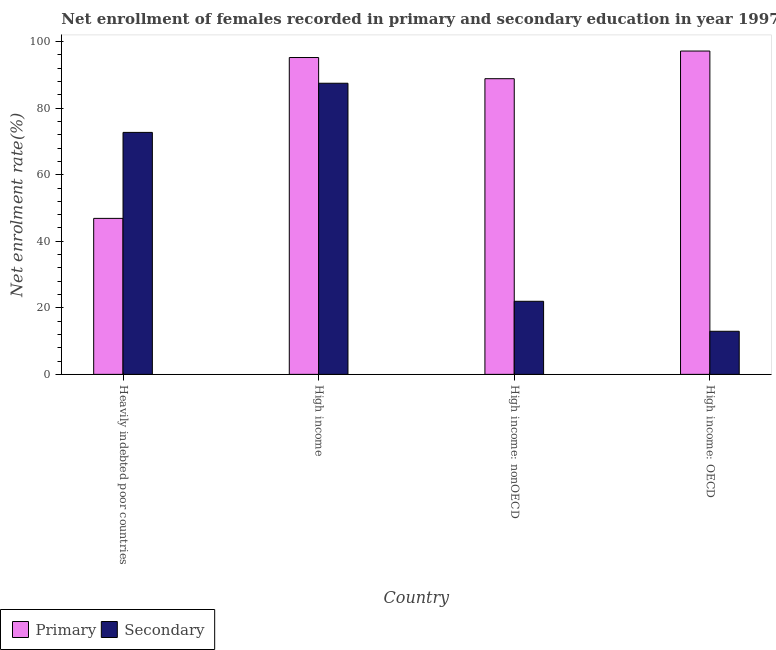How many different coloured bars are there?
Your answer should be compact. 2. How many groups of bars are there?
Ensure brevity in your answer.  4. Are the number of bars per tick equal to the number of legend labels?
Your answer should be compact. Yes. Are the number of bars on each tick of the X-axis equal?
Ensure brevity in your answer.  Yes. How many bars are there on the 3rd tick from the left?
Keep it short and to the point. 2. What is the label of the 1st group of bars from the left?
Your answer should be compact. Heavily indebted poor countries. What is the enrollment rate in secondary education in High income: OECD?
Offer a very short reply. 12.95. Across all countries, what is the maximum enrollment rate in secondary education?
Offer a terse response. 87.49. Across all countries, what is the minimum enrollment rate in primary education?
Offer a very short reply. 46.88. In which country was the enrollment rate in primary education maximum?
Provide a short and direct response. High income: OECD. In which country was the enrollment rate in secondary education minimum?
Provide a short and direct response. High income: OECD. What is the total enrollment rate in primary education in the graph?
Provide a short and direct response. 328.13. What is the difference between the enrollment rate in primary education in Heavily indebted poor countries and that in High income: OECD?
Provide a short and direct response. -50.29. What is the difference between the enrollment rate in secondary education in High income: nonOECD and the enrollment rate in primary education in High income?
Offer a very short reply. -73.26. What is the average enrollment rate in secondary education per country?
Your response must be concise. 48.78. What is the difference between the enrollment rate in primary education and enrollment rate in secondary education in High income: nonOECD?
Offer a terse response. 66.9. In how many countries, is the enrollment rate in primary education greater than 48 %?
Give a very brief answer. 3. What is the ratio of the enrollment rate in primary education in High income to that in High income: nonOECD?
Provide a succinct answer. 1.07. Is the difference between the enrollment rate in primary education in High income and High income: nonOECD greater than the difference between the enrollment rate in secondary education in High income and High income: nonOECD?
Offer a very short reply. No. What is the difference between the highest and the second highest enrollment rate in secondary education?
Make the answer very short. 14.77. What is the difference between the highest and the lowest enrollment rate in primary education?
Make the answer very short. 50.29. In how many countries, is the enrollment rate in secondary education greater than the average enrollment rate in secondary education taken over all countries?
Provide a short and direct response. 2. Is the sum of the enrollment rate in secondary education in Heavily indebted poor countries and High income: OECD greater than the maximum enrollment rate in primary education across all countries?
Your answer should be very brief. No. What does the 1st bar from the left in High income: OECD represents?
Provide a succinct answer. Primary. What does the 2nd bar from the right in Heavily indebted poor countries represents?
Your answer should be compact. Primary. How many bars are there?
Provide a succinct answer. 8. Are the values on the major ticks of Y-axis written in scientific E-notation?
Your answer should be very brief. No. Does the graph contain any zero values?
Give a very brief answer. No. Does the graph contain grids?
Your response must be concise. No. How many legend labels are there?
Your answer should be very brief. 2. What is the title of the graph?
Provide a succinct answer. Net enrollment of females recorded in primary and secondary education in year 1997. Does "Current education expenditure" appear as one of the legend labels in the graph?
Offer a terse response. No. What is the label or title of the X-axis?
Offer a terse response. Country. What is the label or title of the Y-axis?
Make the answer very short. Net enrolment rate(%). What is the Net enrolment rate(%) of Primary in Heavily indebted poor countries?
Ensure brevity in your answer.  46.88. What is the Net enrolment rate(%) of Secondary in Heavily indebted poor countries?
Offer a very short reply. 72.72. What is the Net enrolment rate(%) in Primary in High income?
Make the answer very short. 95.22. What is the Net enrolment rate(%) in Secondary in High income?
Ensure brevity in your answer.  87.49. What is the Net enrolment rate(%) of Primary in High income: nonOECD?
Ensure brevity in your answer.  88.86. What is the Net enrolment rate(%) of Secondary in High income: nonOECD?
Provide a short and direct response. 21.96. What is the Net enrolment rate(%) in Primary in High income: OECD?
Make the answer very short. 97.17. What is the Net enrolment rate(%) in Secondary in High income: OECD?
Give a very brief answer. 12.95. Across all countries, what is the maximum Net enrolment rate(%) in Primary?
Make the answer very short. 97.17. Across all countries, what is the maximum Net enrolment rate(%) of Secondary?
Your answer should be compact. 87.49. Across all countries, what is the minimum Net enrolment rate(%) of Primary?
Your answer should be compact. 46.88. Across all countries, what is the minimum Net enrolment rate(%) in Secondary?
Give a very brief answer. 12.95. What is the total Net enrolment rate(%) of Primary in the graph?
Ensure brevity in your answer.  328.13. What is the total Net enrolment rate(%) of Secondary in the graph?
Your response must be concise. 195.13. What is the difference between the Net enrolment rate(%) in Primary in Heavily indebted poor countries and that in High income?
Your response must be concise. -48.34. What is the difference between the Net enrolment rate(%) of Secondary in Heavily indebted poor countries and that in High income?
Your answer should be compact. -14.77. What is the difference between the Net enrolment rate(%) of Primary in Heavily indebted poor countries and that in High income: nonOECD?
Offer a terse response. -41.98. What is the difference between the Net enrolment rate(%) in Secondary in Heavily indebted poor countries and that in High income: nonOECD?
Provide a succinct answer. 50.76. What is the difference between the Net enrolment rate(%) in Primary in Heavily indebted poor countries and that in High income: OECD?
Give a very brief answer. -50.29. What is the difference between the Net enrolment rate(%) in Secondary in Heavily indebted poor countries and that in High income: OECD?
Your response must be concise. 59.77. What is the difference between the Net enrolment rate(%) in Primary in High income and that in High income: nonOECD?
Offer a terse response. 6.36. What is the difference between the Net enrolment rate(%) of Secondary in High income and that in High income: nonOECD?
Provide a succinct answer. 65.53. What is the difference between the Net enrolment rate(%) in Primary in High income and that in High income: OECD?
Provide a short and direct response. -1.95. What is the difference between the Net enrolment rate(%) of Secondary in High income and that in High income: OECD?
Your answer should be very brief. 74.54. What is the difference between the Net enrolment rate(%) in Primary in High income: nonOECD and that in High income: OECD?
Provide a short and direct response. -8.31. What is the difference between the Net enrolment rate(%) of Secondary in High income: nonOECD and that in High income: OECD?
Make the answer very short. 9.01. What is the difference between the Net enrolment rate(%) in Primary in Heavily indebted poor countries and the Net enrolment rate(%) in Secondary in High income?
Your answer should be compact. -40.62. What is the difference between the Net enrolment rate(%) of Primary in Heavily indebted poor countries and the Net enrolment rate(%) of Secondary in High income: nonOECD?
Your answer should be compact. 24.91. What is the difference between the Net enrolment rate(%) in Primary in Heavily indebted poor countries and the Net enrolment rate(%) in Secondary in High income: OECD?
Keep it short and to the point. 33.93. What is the difference between the Net enrolment rate(%) of Primary in High income and the Net enrolment rate(%) of Secondary in High income: nonOECD?
Make the answer very short. 73.26. What is the difference between the Net enrolment rate(%) of Primary in High income and the Net enrolment rate(%) of Secondary in High income: OECD?
Provide a short and direct response. 82.27. What is the difference between the Net enrolment rate(%) of Primary in High income: nonOECD and the Net enrolment rate(%) of Secondary in High income: OECD?
Your response must be concise. 75.91. What is the average Net enrolment rate(%) in Primary per country?
Your answer should be very brief. 82.03. What is the average Net enrolment rate(%) in Secondary per country?
Provide a short and direct response. 48.78. What is the difference between the Net enrolment rate(%) in Primary and Net enrolment rate(%) in Secondary in Heavily indebted poor countries?
Make the answer very short. -25.84. What is the difference between the Net enrolment rate(%) of Primary and Net enrolment rate(%) of Secondary in High income?
Offer a terse response. 7.73. What is the difference between the Net enrolment rate(%) in Primary and Net enrolment rate(%) in Secondary in High income: nonOECD?
Offer a terse response. 66.9. What is the difference between the Net enrolment rate(%) in Primary and Net enrolment rate(%) in Secondary in High income: OECD?
Offer a terse response. 84.22. What is the ratio of the Net enrolment rate(%) of Primary in Heavily indebted poor countries to that in High income?
Ensure brevity in your answer.  0.49. What is the ratio of the Net enrolment rate(%) of Secondary in Heavily indebted poor countries to that in High income?
Offer a terse response. 0.83. What is the ratio of the Net enrolment rate(%) in Primary in Heavily indebted poor countries to that in High income: nonOECD?
Offer a very short reply. 0.53. What is the ratio of the Net enrolment rate(%) of Secondary in Heavily indebted poor countries to that in High income: nonOECD?
Your answer should be very brief. 3.31. What is the ratio of the Net enrolment rate(%) in Primary in Heavily indebted poor countries to that in High income: OECD?
Offer a very short reply. 0.48. What is the ratio of the Net enrolment rate(%) of Secondary in Heavily indebted poor countries to that in High income: OECD?
Provide a short and direct response. 5.61. What is the ratio of the Net enrolment rate(%) of Primary in High income to that in High income: nonOECD?
Keep it short and to the point. 1.07. What is the ratio of the Net enrolment rate(%) in Secondary in High income to that in High income: nonOECD?
Provide a succinct answer. 3.98. What is the ratio of the Net enrolment rate(%) in Primary in High income to that in High income: OECD?
Your answer should be compact. 0.98. What is the ratio of the Net enrolment rate(%) of Secondary in High income to that in High income: OECD?
Offer a terse response. 6.76. What is the ratio of the Net enrolment rate(%) of Primary in High income: nonOECD to that in High income: OECD?
Give a very brief answer. 0.91. What is the ratio of the Net enrolment rate(%) in Secondary in High income: nonOECD to that in High income: OECD?
Your answer should be very brief. 1.7. What is the difference between the highest and the second highest Net enrolment rate(%) of Primary?
Provide a succinct answer. 1.95. What is the difference between the highest and the second highest Net enrolment rate(%) of Secondary?
Provide a succinct answer. 14.77. What is the difference between the highest and the lowest Net enrolment rate(%) in Primary?
Your response must be concise. 50.29. What is the difference between the highest and the lowest Net enrolment rate(%) in Secondary?
Offer a terse response. 74.54. 